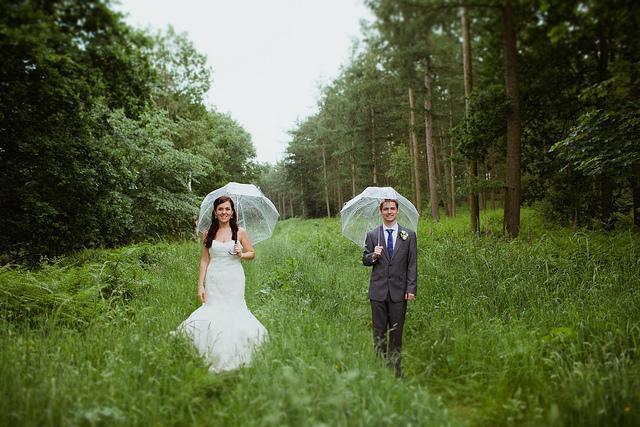How many umbrellas are open?
Give a very brief answer. 2. How many people are there?
Give a very brief answer. 2. How many umbrellas are in the photo?
Give a very brief answer. 2. 